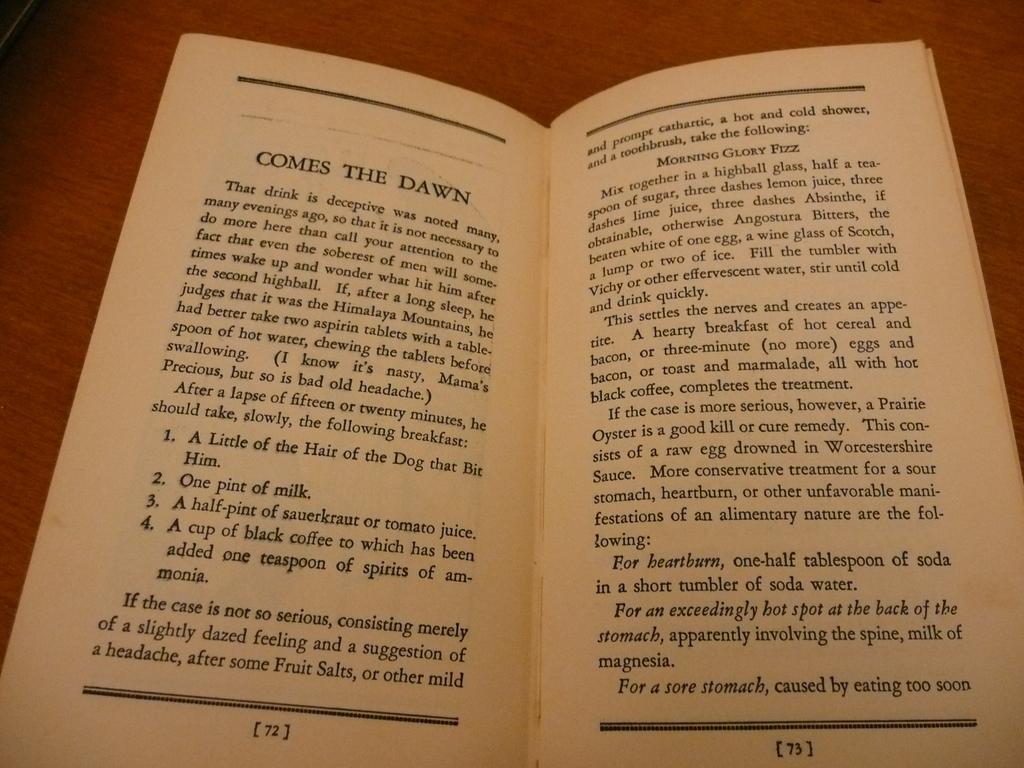What is the title of the pages of the book?
Make the answer very short. Comes the dawn. What is step 2 on page 72?
Ensure brevity in your answer.  One pint of milk. 